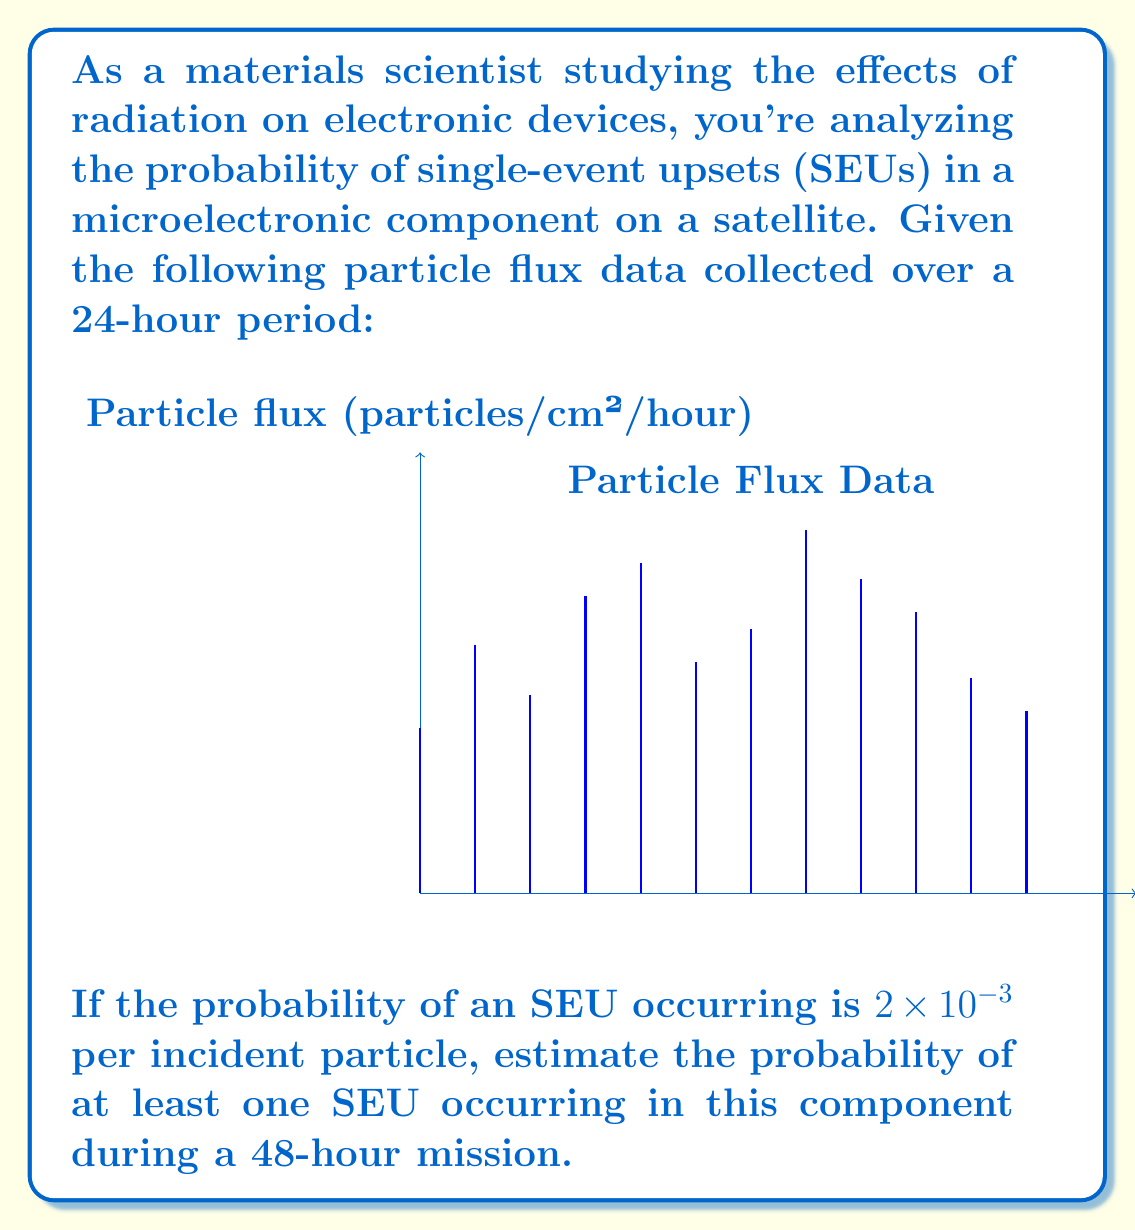Can you solve this math problem? To solve this problem, we'll follow these steps:

1) Calculate the average particle flux:
   $$\text{Average flux} = \frac{\sum_{i=1}^{12} \text{flux}_i}{12} = \frac{10+15+12+18+20+14+16+22+19+17+13+11}{12} = \frac{187}{12} \approx 15.58 \text{ particles/cm²/hour}$$

2) Calculate the total number of particles incident over 48 hours:
   $$\text{Total particles} = 15.58 \text{ particles/cm²/hour} \times 48 \text{ hours} = 747.84 \text{ particles/cm²}$$

3) Calculate the probability of an SEU for each particle:
   $$P(\text{SEU per particle}) = 2 \times 10^{-3}$$

4) Calculate the probability of no SEU occurring for a single particle:
   $$P(\text{No SEU per particle}) = 1 - 2 \times 10^{-3} = 0.998$$

5) Calculate the probability of no SEU occurring for all particles over 48 hours:
   $$P(\text{No SEU for all particles}) = (0.998)^{747.84} \approx 0.2236$$

6) Therefore, the probability of at least one SEU occurring is:
   $$P(\text{At least one SEU}) = 1 - P(\text{No SEU for all particles}) = 1 - 0.2236 \approx 0.7764$$
Answer: $0.7764$ or $77.64\%$ 